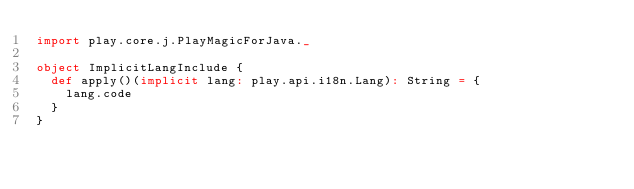Convert code to text. <code><loc_0><loc_0><loc_500><loc_500><_Scala_>import play.core.j.PlayMagicForJava._

object ImplicitLangInclude {
  def apply()(implicit lang: play.api.i18n.Lang): String = {
    lang.code
  }
}
</code> 